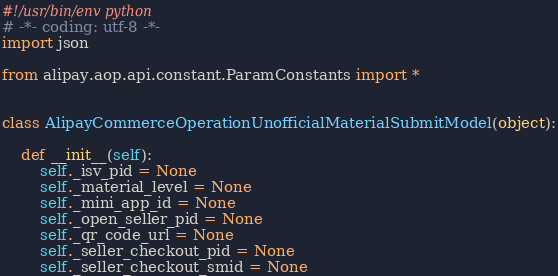<code> <loc_0><loc_0><loc_500><loc_500><_Python_>#!/usr/bin/env python
# -*- coding: utf-8 -*-
import json

from alipay.aop.api.constant.ParamConstants import *


class AlipayCommerceOperationUnofficialMaterialSubmitModel(object):

    def __init__(self):
        self._isv_pid = None
        self._material_level = None
        self._mini_app_id = None
        self._open_seller_pid = None
        self._qr_code_url = None
        self._seller_checkout_pid = None
        self._seller_checkout_smid = None</code> 